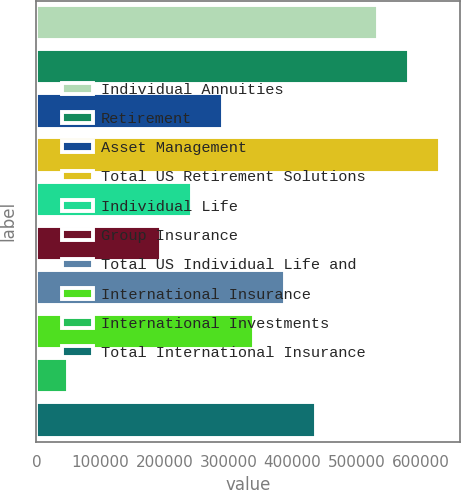Convert chart to OTSL. <chart><loc_0><loc_0><loc_500><loc_500><bar_chart><fcel>Individual Annuities<fcel>Retirement<fcel>Asset Management<fcel>Total US Retirement Solutions<fcel>Individual Life<fcel>Group Insurance<fcel>Total US Individual Life and<fcel>International Insurance<fcel>International Investments<fcel>Total International Insurance<nl><fcel>534266<fcel>582719<fcel>292000<fcel>631173<fcel>243547<fcel>195094<fcel>388907<fcel>340453<fcel>49734.2<fcel>437360<nl></chart> 